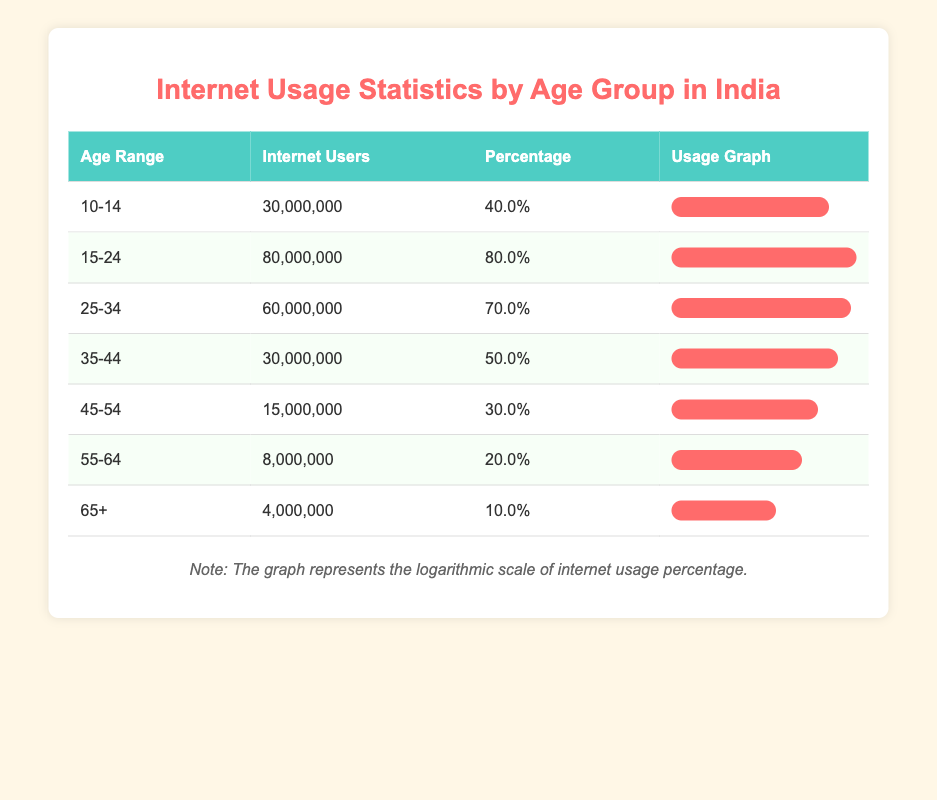What is the age group with the highest number of internet users? Looking through the table, the age group "15-24" is listed with 80,000,000 internet users, which is more than any other age group.
Answer: 15-24 What percentage of internet users are between the ages of 25 and 34? The table shows that the age group "25-34" has an internet usage percentage of 70%.
Answer: 70.0% How many internet users are in the 45-54 age group? From the table, the age group "45-54" has 15,000,000 internet users.
Answer: 15,000,000 What is the total number of internet users across all age groups? By adding the number of internet users from all age groups: 30,000,000 + 80,000,000 + 60,000,000 + 30,000,000 + 15,000,000 + 8,000,000 + 4,000,000 = 227,000,000.
Answer: 227,000,000 Is the percentage of internet users in the age group 55-64 more than 25%? The percentage of internet users in the age group "55-64" is 20%, which is less than 25%.
Answer: No What is the average number of internet users in the age groups of 35-44 and 45-54 combined? The number of internet users in "35-44" is 30,000,000 and in "45-54" is 15,000,000. Adding these gives 45,000,000. Then calculating the average for these two groups: 45,000,000 / 2 = 22,500,000.
Answer: 22,500,000 Which age group has the lowest percentage of internet usage and what is that percentage? The age group "65+" has the lowest percentage at 10.0%, as seen in the table.
Answer: 10.0% How many more internet users are in the 15-24 age group compared to the 55-64 age group? The "15-24" age group has 80,000,000 internet users, while "55-64" has 8,000,000. The difference is 80,000,000 - 8,000,000 = 72,000,000.
Answer: 72,000,000 